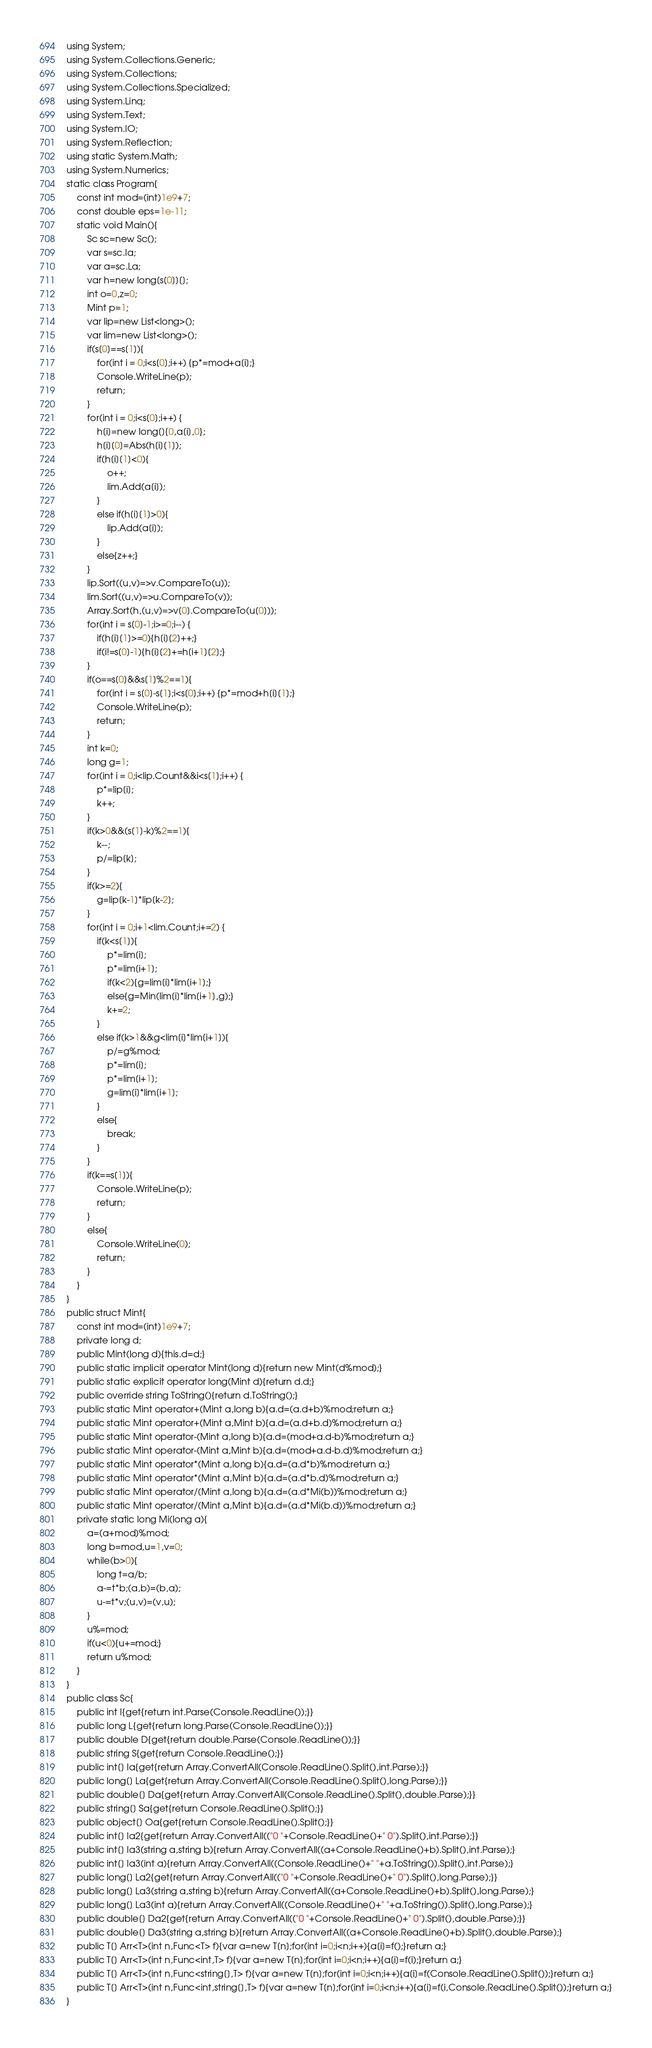<code> <loc_0><loc_0><loc_500><loc_500><_C#_>using System;
using System.Collections.Generic;
using System.Collections;
using System.Collections.Specialized;
using System.Linq;
using System.Text;
using System.IO;
using System.Reflection;
using static System.Math;
using System.Numerics;
static class Program{
	const int mod=(int)1e9+7;
	const double eps=1e-11;
	static void Main(){
		Sc sc=new Sc();
		var s=sc.Ia;
		var a=sc.La;
		var h=new long[s[0]][];
		int o=0,z=0;
		Mint p=1;
		var lip=new List<long>();
		var lim=new List<long>();
		if(s[0]==s[1]){
			for(int i = 0;i<s[0];i++) {p*=mod+a[i];}
			Console.WriteLine(p);
			return;
		}
		for(int i = 0;i<s[0];i++) {
			h[i]=new long[]{0,a[i],0};
			h[i][0]=Abs(h[i][1]);
			if(h[i][1]<0){
				o++;
				lim.Add(a[i]);
			}
			else if(h[i][1]>0){
				lip.Add(a[i]);
			}
			else{z++;}
		}
		lip.Sort((u,v)=>v.CompareTo(u));
		lim.Sort((u,v)=>u.CompareTo(v));
		Array.Sort(h,(u,v)=>v[0].CompareTo(u[0]));
		for(int i = s[0]-1;i>=0;i--) {
			if(h[i][1]>=0){h[i][2]++;}
			if(i!=s[0]-1){h[i][2]+=h[i+1][2];}
		}
		if(o==s[0]&&s[1]%2==1){
			for(int i = s[0]-s[1];i<s[0];i++) {p*=mod+h[i][1];}
			Console.WriteLine(p);
			return;
		}
		int k=0;
		long g=1;
		for(int i = 0;i<lip.Count&&i<s[1];i++) {
			p*=lip[i];
			k++;
		}
		if(k>0&&(s[1]-k)%2==1){
			k--;
			p/=lip[k];
		}
		if(k>=2){
			g=lip[k-1]*lip[k-2];
		}
		for(int i = 0;i+1<lim.Count;i+=2) {
			if(k<s[1]){
				p*=lim[i];
				p*=lim[i+1];
				if(k<2){g=lim[i]*lim[i+1];}
				else{g=Min(lim[i]*lim[i+1],g);}
				k+=2;
			}
			else if(k>1&&g<lim[i]*lim[i+1]){
				p/=g%mod;
				p*=lim[i];
				p*=lim[i+1];
				g=lim[i]*lim[i+1];
			}
			else{
				break;
			}
		}
		if(k==s[1]){
			Console.WriteLine(p);
			return;
		}
		else{
			Console.WriteLine(0);
			return;
		}
	}
}
public struct Mint{
	const int mod=(int)1e9+7;
	private long d;
	public Mint(long d){this.d=d;}
	public static implicit operator Mint(long d){return new Mint(d%mod);}
	public static explicit operator long(Mint d){return d.d;}
	public override string ToString(){return d.ToString();}
	public static Mint operator+(Mint a,long b){a.d=(a.d+b)%mod;return a;}
	public static Mint operator+(Mint a,Mint b){a.d=(a.d+b.d)%mod;return a;}
	public static Mint operator-(Mint a,long b){a.d=(mod+a.d-b)%mod;return a;}
	public static Mint operator-(Mint a,Mint b){a.d=(mod+a.d-b.d)%mod;return a;}
	public static Mint operator*(Mint a,long b){a.d=(a.d*b)%mod;return a;}
	public static Mint operator*(Mint a,Mint b){a.d=(a.d*b.d)%mod;return a;}
	public static Mint operator/(Mint a,long b){a.d=(a.d*Mi(b))%mod;return a;}
	public static Mint operator/(Mint a,Mint b){a.d=(a.d*Mi(b.d))%mod;return a;}
	private static long Mi(long a){
		a=(a+mod)%mod;
		long b=mod,u=1,v=0;
		while(b>0){
			long t=a/b;
			a-=t*b;(a,b)=(b,a);
			u-=t*v;(u,v)=(v,u);
		}
		u%=mod;
		if(u<0){u+=mod;}
		return u%mod;
	}
}
public class Sc{
	public int I{get{return int.Parse(Console.ReadLine());}}
	public long L{get{return long.Parse(Console.ReadLine());}}
	public double D{get{return double.Parse(Console.ReadLine());}}
	public string S{get{return Console.ReadLine();}}
	public int[] Ia{get{return Array.ConvertAll(Console.ReadLine().Split(),int.Parse);}}
	public long[] La{get{return Array.ConvertAll(Console.ReadLine().Split(),long.Parse);}}
	public double[] Da{get{return Array.ConvertAll(Console.ReadLine().Split(),double.Parse);}}
	public string[] Sa{get{return Console.ReadLine().Split();}}
	public object[] Oa{get{return Console.ReadLine().Split();}}
	public int[] Ia2{get{return Array.ConvertAll(("0 "+Console.ReadLine()+" 0").Split(),int.Parse);}}
	public int[] Ia3(string a,string b){return Array.ConvertAll((a+Console.ReadLine()+b).Split(),int.Parse);}
	public int[] Ia3(int a){return Array.ConvertAll((Console.ReadLine()+" "+a.ToString()).Split(),int.Parse);}
	public long[] La2{get{return Array.ConvertAll(("0 "+Console.ReadLine()+" 0").Split(),long.Parse);}}
	public long[] La3(string a,string b){return Array.ConvertAll((a+Console.ReadLine()+b).Split(),long.Parse);}
	public long[] La3(int a){return Array.ConvertAll((Console.ReadLine()+" "+a.ToString()).Split(),long.Parse);}
	public double[] Da2{get{return Array.ConvertAll(("0 "+Console.ReadLine()+" 0").Split(),double.Parse);}}
	public double[] Da3(string a,string b){return Array.ConvertAll((a+Console.ReadLine()+b).Split(),double.Parse);}
	public T[] Arr<T>(int n,Func<T> f){var a=new T[n];for(int i=0;i<n;i++){a[i]=f();}return a;}
	public T[] Arr<T>(int n,Func<int,T> f){var a=new T[n];for(int i=0;i<n;i++){a[i]=f(i);}return a;}
	public T[] Arr<T>(int n,Func<string[],T> f){var a=new T[n];for(int i=0;i<n;i++){a[i]=f(Console.ReadLine().Split());}return a;}
	public T[] Arr<T>(int n,Func<int,string[],T> f){var a=new T[n];for(int i=0;i<n;i++){a[i]=f(i,Console.ReadLine().Split());}return a;}
}</code> 